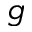<formula> <loc_0><loc_0><loc_500><loc_500>g</formula> 